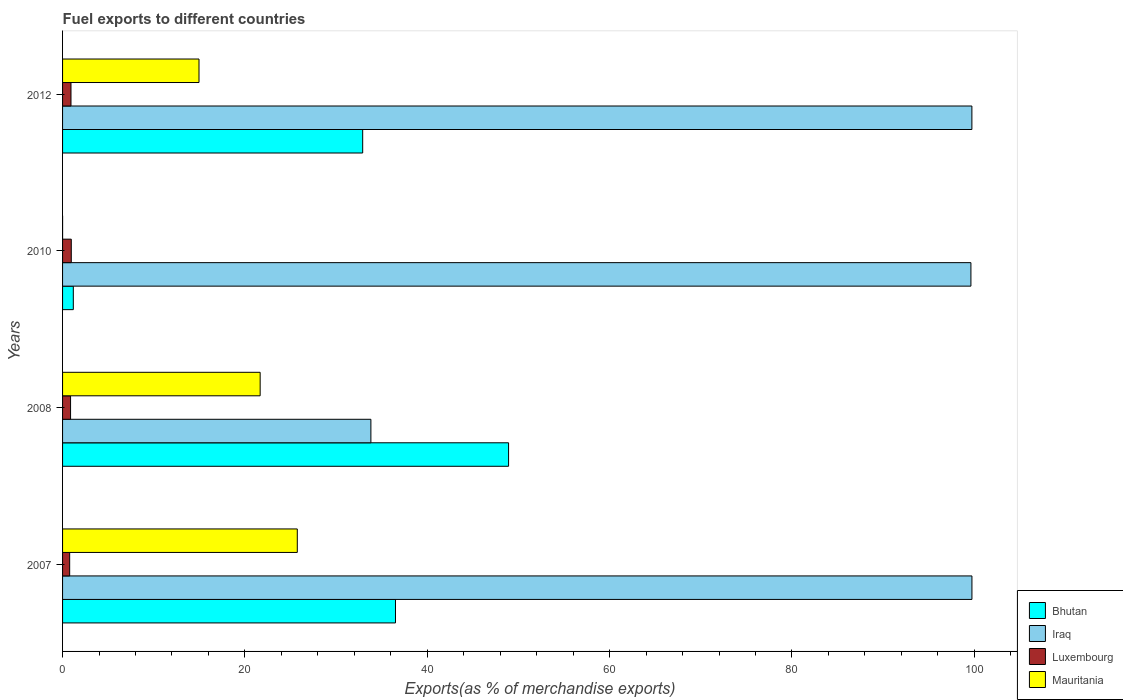How many different coloured bars are there?
Offer a very short reply. 4. How many groups of bars are there?
Offer a terse response. 4. What is the label of the 3rd group of bars from the top?
Offer a terse response. 2008. In how many cases, is the number of bars for a given year not equal to the number of legend labels?
Your answer should be very brief. 0. What is the percentage of exports to different countries in Mauritania in 2010?
Your answer should be very brief. 0. Across all years, what is the maximum percentage of exports to different countries in Iraq?
Make the answer very short. 99.74. Across all years, what is the minimum percentage of exports to different countries in Iraq?
Your response must be concise. 33.82. In which year was the percentage of exports to different countries in Luxembourg maximum?
Ensure brevity in your answer.  2010. What is the total percentage of exports to different countries in Luxembourg in the graph?
Offer a terse response. 3.53. What is the difference between the percentage of exports to different countries in Luxembourg in 2008 and that in 2012?
Provide a short and direct response. -0.05. What is the difference between the percentage of exports to different countries in Bhutan in 2010 and the percentage of exports to different countries in Luxembourg in 2012?
Keep it short and to the point. 0.26. What is the average percentage of exports to different countries in Luxembourg per year?
Provide a short and direct response. 0.88. In the year 2007, what is the difference between the percentage of exports to different countries in Bhutan and percentage of exports to different countries in Iraq?
Provide a short and direct response. -63.23. In how many years, is the percentage of exports to different countries in Mauritania greater than 68 %?
Give a very brief answer. 0. What is the ratio of the percentage of exports to different countries in Iraq in 2010 to that in 2012?
Provide a succinct answer. 1. Is the percentage of exports to different countries in Bhutan in 2010 less than that in 2012?
Your response must be concise. Yes. What is the difference between the highest and the second highest percentage of exports to different countries in Mauritania?
Your response must be concise. 4.07. What is the difference between the highest and the lowest percentage of exports to different countries in Mauritania?
Your response must be concise. 25.74. In how many years, is the percentage of exports to different countries in Iraq greater than the average percentage of exports to different countries in Iraq taken over all years?
Make the answer very short. 3. Is it the case that in every year, the sum of the percentage of exports to different countries in Bhutan and percentage of exports to different countries in Luxembourg is greater than the sum of percentage of exports to different countries in Iraq and percentage of exports to different countries in Mauritania?
Provide a short and direct response. No. What does the 4th bar from the top in 2010 represents?
Offer a terse response. Bhutan. What does the 4th bar from the bottom in 2012 represents?
Your answer should be very brief. Mauritania. How many bars are there?
Your answer should be compact. 16. Are all the bars in the graph horizontal?
Ensure brevity in your answer.  Yes. Does the graph contain any zero values?
Ensure brevity in your answer.  No. What is the title of the graph?
Offer a terse response. Fuel exports to different countries. Does "Congo (Democratic)" appear as one of the legend labels in the graph?
Make the answer very short. No. What is the label or title of the X-axis?
Offer a terse response. Exports(as % of merchandise exports). What is the Exports(as % of merchandise exports) in Bhutan in 2007?
Ensure brevity in your answer.  36.51. What is the Exports(as % of merchandise exports) in Iraq in 2007?
Offer a very short reply. 99.74. What is the Exports(as % of merchandise exports) of Luxembourg in 2007?
Give a very brief answer. 0.78. What is the Exports(as % of merchandise exports) in Mauritania in 2007?
Your answer should be compact. 25.74. What is the Exports(as % of merchandise exports) in Bhutan in 2008?
Provide a short and direct response. 48.92. What is the Exports(as % of merchandise exports) of Iraq in 2008?
Your answer should be very brief. 33.82. What is the Exports(as % of merchandise exports) of Luxembourg in 2008?
Provide a short and direct response. 0.88. What is the Exports(as % of merchandise exports) in Mauritania in 2008?
Provide a succinct answer. 21.67. What is the Exports(as % of merchandise exports) of Bhutan in 2010?
Offer a very short reply. 1.18. What is the Exports(as % of merchandise exports) of Iraq in 2010?
Provide a succinct answer. 99.63. What is the Exports(as % of merchandise exports) in Luxembourg in 2010?
Your answer should be very brief. 0.96. What is the Exports(as % of merchandise exports) of Mauritania in 2010?
Your response must be concise. 0. What is the Exports(as % of merchandise exports) of Bhutan in 2012?
Keep it short and to the point. 32.92. What is the Exports(as % of merchandise exports) in Iraq in 2012?
Keep it short and to the point. 99.73. What is the Exports(as % of merchandise exports) of Luxembourg in 2012?
Offer a very short reply. 0.92. What is the Exports(as % of merchandise exports) of Mauritania in 2012?
Provide a short and direct response. 14.96. Across all years, what is the maximum Exports(as % of merchandise exports) in Bhutan?
Give a very brief answer. 48.92. Across all years, what is the maximum Exports(as % of merchandise exports) in Iraq?
Keep it short and to the point. 99.74. Across all years, what is the maximum Exports(as % of merchandise exports) of Luxembourg?
Give a very brief answer. 0.96. Across all years, what is the maximum Exports(as % of merchandise exports) of Mauritania?
Your answer should be compact. 25.74. Across all years, what is the minimum Exports(as % of merchandise exports) of Bhutan?
Offer a terse response. 1.18. Across all years, what is the minimum Exports(as % of merchandise exports) in Iraq?
Provide a succinct answer. 33.82. Across all years, what is the minimum Exports(as % of merchandise exports) in Luxembourg?
Your answer should be compact. 0.78. Across all years, what is the minimum Exports(as % of merchandise exports) in Mauritania?
Your answer should be compact. 0. What is the total Exports(as % of merchandise exports) in Bhutan in the graph?
Offer a very short reply. 119.53. What is the total Exports(as % of merchandise exports) in Iraq in the graph?
Provide a succinct answer. 332.92. What is the total Exports(as % of merchandise exports) of Luxembourg in the graph?
Keep it short and to the point. 3.53. What is the total Exports(as % of merchandise exports) of Mauritania in the graph?
Offer a very short reply. 62.38. What is the difference between the Exports(as % of merchandise exports) in Bhutan in 2007 and that in 2008?
Provide a succinct answer. -12.4. What is the difference between the Exports(as % of merchandise exports) in Iraq in 2007 and that in 2008?
Offer a terse response. 65.92. What is the difference between the Exports(as % of merchandise exports) in Luxembourg in 2007 and that in 2008?
Your response must be concise. -0.1. What is the difference between the Exports(as % of merchandise exports) of Mauritania in 2007 and that in 2008?
Keep it short and to the point. 4.07. What is the difference between the Exports(as % of merchandise exports) of Bhutan in 2007 and that in 2010?
Provide a succinct answer. 35.34. What is the difference between the Exports(as % of merchandise exports) of Iraq in 2007 and that in 2010?
Offer a terse response. 0.11. What is the difference between the Exports(as % of merchandise exports) of Luxembourg in 2007 and that in 2010?
Ensure brevity in your answer.  -0.18. What is the difference between the Exports(as % of merchandise exports) of Mauritania in 2007 and that in 2010?
Offer a terse response. 25.74. What is the difference between the Exports(as % of merchandise exports) of Bhutan in 2007 and that in 2012?
Provide a short and direct response. 3.6. What is the difference between the Exports(as % of merchandise exports) in Iraq in 2007 and that in 2012?
Provide a succinct answer. 0.01. What is the difference between the Exports(as % of merchandise exports) in Luxembourg in 2007 and that in 2012?
Provide a succinct answer. -0.14. What is the difference between the Exports(as % of merchandise exports) in Mauritania in 2007 and that in 2012?
Offer a very short reply. 10.78. What is the difference between the Exports(as % of merchandise exports) of Bhutan in 2008 and that in 2010?
Ensure brevity in your answer.  47.74. What is the difference between the Exports(as % of merchandise exports) of Iraq in 2008 and that in 2010?
Your response must be concise. -65.81. What is the difference between the Exports(as % of merchandise exports) in Luxembourg in 2008 and that in 2010?
Provide a short and direct response. -0.08. What is the difference between the Exports(as % of merchandise exports) in Mauritania in 2008 and that in 2010?
Offer a terse response. 21.67. What is the difference between the Exports(as % of merchandise exports) in Bhutan in 2008 and that in 2012?
Provide a short and direct response. 16. What is the difference between the Exports(as % of merchandise exports) of Iraq in 2008 and that in 2012?
Ensure brevity in your answer.  -65.92. What is the difference between the Exports(as % of merchandise exports) in Luxembourg in 2008 and that in 2012?
Offer a very short reply. -0.05. What is the difference between the Exports(as % of merchandise exports) of Mauritania in 2008 and that in 2012?
Provide a short and direct response. 6.71. What is the difference between the Exports(as % of merchandise exports) of Bhutan in 2010 and that in 2012?
Ensure brevity in your answer.  -31.74. What is the difference between the Exports(as % of merchandise exports) of Iraq in 2010 and that in 2012?
Provide a succinct answer. -0.11. What is the difference between the Exports(as % of merchandise exports) of Luxembourg in 2010 and that in 2012?
Give a very brief answer. 0.03. What is the difference between the Exports(as % of merchandise exports) in Mauritania in 2010 and that in 2012?
Make the answer very short. -14.96. What is the difference between the Exports(as % of merchandise exports) of Bhutan in 2007 and the Exports(as % of merchandise exports) of Iraq in 2008?
Provide a short and direct response. 2.7. What is the difference between the Exports(as % of merchandise exports) in Bhutan in 2007 and the Exports(as % of merchandise exports) in Luxembourg in 2008?
Your answer should be very brief. 35.64. What is the difference between the Exports(as % of merchandise exports) of Bhutan in 2007 and the Exports(as % of merchandise exports) of Mauritania in 2008?
Give a very brief answer. 14.84. What is the difference between the Exports(as % of merchandise exports) in Iraq in 2007 and the Exports(as % of merchandise exports) in Luxembourg in 2008?
Make the answer very short. 98.86. What is the difference between the Exports(as % of merchandise exports) of Iraq in 2007 and the Exports(as % of merchandise exports) of Mauritania in 2008?
Keep it short and to the point. 78.07. What is the difference between the Exports(as % of merchandise exports) in Luxembourg in 2007 and the Exports(as % of merchandise exports) in Mauritania in 2008?
Provide a short and direct response. -20.89. What is the difference between the Exports(as % of merchandise exports) of Bhutan in 2007 and the Exports(as % of merchandise exports) of Iraq in 2010?
Keep it short and to the point. -63.11. What is the difference between the Exports(as % of merchandise exports) of Bhutan in 2007 and the Exports(as % of merchandise exports) of Luxembourg in 2010?
Offer a very short reply. 35.56. What is the difference between the Exports(as % of merchandise exports) of Bhutan in 2007 and the Exports(as % of merchandise exports) of Mauritania in 2010?
Make the answer very short. 36.51. What is the difference between the Exports(as % of merchandise exports) in Iraq in 2007 and the Exports(as % of merchandise exports) in Luxembourg in 2010?
Give a very brief answer. 98.78. What is the difference between the Exports(as % of merchandise exports) of Iraq in 2007 and the Exports(as % of merchandise exports) of Mauritania in 2010?
Offer a very short reply. 99.74. What is the difference between the Exports(as % of merchandise exports) of Luxembourg in 2007 and the Exports(as % of merchandise exports) of Mauritania in 2010?
Ensure brevity in your answer.  0.78. What is the difference between the Exports(as % of merchandise exports) in Bhutan in 2007 and the Exports(as % of merchandise exports) in Iraq in 2012?
Offer a very short reply. -63.22. What is the difference between the Exports(as % of merchandise exports) in Bhutan in 2007 and the Exports(as % of merchandise exports) in Luxembourg in 2012?
Keep it short and to the point. 35.59. What is the difference between the Exports(as % of merchandise exports) in Bhutan in 2007 and the Exports(as % of merchandise exports) in Mauritania in 2012?
Ensure brevity in your answer.  21.55. What is the difference between the Exports(as % of merchandise exports) of Iraq in 2007 and the Exports(as % of merchandise exports) of Luxembourg in 2012?
Your response must be concise. 98.82. What is the difference between the Exports(as % of merchandise exports) in Iraq in 2007 and the Exports(as % of merchandise exports) in Mauritania in 2012?
Provide a succinct answer. 84.78. What is the difference between the Exports(as % of merchandise exports) in Luxembourg in 2007 and the Exports(as % of merchandise exports) in Mauritania in 2012?
Give a very brief answer. -14.18. What is the difference between the Exports(as % of merchandise exports) in Bhutan in 2008 and the Exports(as % of merchandise exports) in Iraq in 2010?
Ensure brevity in your answer.  -50.71. What is the difference between the Exports(as % of merchandise exports) in Bhutan in 2008 and the Exports(as % of merchandise exports) in Luxembourg in 2010?
Your response must be concise. 47.96. What is the difference between the Exports(as % of merchandise exports) of Bhutan in 2008 and the Exports(as % of merchandise exports) of Mauritania in 2010?
Offer a very short reply. 48.92. What is the difference between the Exports(as % of merchandise exports) of Iraq in 2008 and the Exports(as % of merchandise exports) of Luxembourg in 2010?
Your answer should be compact. 32.86. What is the difference between the Exports(as % of merchandise exports) of Iraq in 2008 and the Exports(as % of merchandise exports) of Mauritania in 2010?
Offer a terse response. 33.82. What is the difference between the Exports(as % of merchandise exports) in Luxembourg in 2008 and the Exports(as % of merchandise exports) in Mauritania in 2010?
Keep it short and to the point. 0.87. What is the difference between the Exports(as % of merchandise exports) of Bhutan in 2008 and the Exports(as % of merchandise exports) of Iraq in 2012?
Ensure brevity in your answer.  -50.82. What is the difference between the Exports(as % of merchandise exports) of Bhutan in 2008 and the Exports(as % of merchandise exports) of Luxembourg in 2012?
Your answer should be very brief. 47.99. What is the difference between the Exports(as % of merchandise exports) in Bhutan in 2008 and the Exports(as % of merchandise exports) in Mauritania in 2012?
Offer a terse response. 33.95. What is the difference between the Exports(as % of merchandise exports) of Iraq in 2008 and the Exports(as % of merchandise exports) of Luxembourg in 2012?
Your answer should be compact. 32.89. What is the difference between the Exports(as % of merchandise exports) in Iraq in 2008 and the Exports(as % of merchandise exports) in Mauritania in 2012?
Offer a terse response. 18.85. What is the difference between the Exports(as % of merchandise exports) of Luxembourg in 2008 and the Exports(as % of merchandise exports) of Mauritania in 2012?
Offer a terse response. -14.09. What is the difference between the Exports(as % of merchandise exports) in Bhutan in 2010 and the Exports(as % of merchandise exports) in Iraq in 2012?
Provide a short and direct response. -98.55. What is the difference between the Exports(as % of merchandise exports) of Bhutan in 2010 and the Exports(as % of merchandise exports) of Luxembourg in 2012?
Your response must be concise. 0.26. What is the difference between the Exports(as % of merchandise exports) of Bhutan in 2010 and the Exports(as % of merchandise exports) of Mauritania in 2012?
Offer a very short reply. -13.78. What is the difference between the Exports(as % of merchandise exports) of Iraq in 2010 and the Exports(as % of merchandise exports) of Luxembourg in 2012?
Provide a succinct answer. 98.7. What is the difference between the Exports(as % of merchandise exports) of Iraq in 2010 and the Exports(as % of merchandise exports) of Mauritania in 2012?
Keep it short and to the point. 84.66. What is the difference between the Exports(as % of merchandise exports) of Luxembourg in 2010 and the Exports(as % of merchandise exports) of Mauritania in 2012?
Offer a terse response. -14.01. What is the average Exports(as % of merchandise exports) in Bhutan per year?
Offer a very short reply. 29.88. What is the average Exports(as % of merchandise exports) of Iraq per year?
Offer a terse response. 83.23. What is the average Exports(as % of merchandise exports) in Luxembourg per year?
Your answer should be compact. 0.88. What is the average Exports(as % of merchandise exports) of Mauritania per year?
Your response must be concise. 15.6. In the year 2007, what is the difference between the Exports(as % of merchandise exports) of Bhutan and Exports(as % of merchandise exports) of Iraq?
Give a very brief answer. -63.23. In the year 2007, what is the difference between the Exports(as % of merchandise exports) in Bhutan and Exports(as % of merchandise exports) in Luxembourg?
Provide a short and direct response. 35.74. In the year 2007, what is the difference between the Exports(as % of merchandise exports) in Bhutan and Exports(as % of merchandise exports) in Mauritania?
Offer a terse response. 10.77. In the year 2007, what is the difference between the Exports(as % of merchandise exports) of Iraq and Exports(as % of merchandise exports) of Luxembourg?
Make the answer very short. 98.96. In the year 2007, what is the difference between the Exports(as % of merchandise exports) in Iraq and Exports(as % of merchandise exports) in Mauritania?
Make the answer very short. 74. In the year 2007, what is the difference between the Exports(as % of merchandise exports) of Luxembourg and Exports(as % of merchandise exports) of Mauritania?
Make the answer very short. -24.97. In the year 2008, what is the difference between the Exports(as % of merchandise exports) of Bhutan and Exports(as % of merchandise exports) of Iraq?
Keep it short and to the point. 15.1. In the year 2008, what is the difference between the Exports(as % of merchandise exports) of Bhutan and Exports(as % of merchandise exports) of Luxembourg?
Keep it short and to the point. 48.04. In the year 2008, what is the difference between the Exports(as % of merchandise exports) of Bhutan and Exports(as % of merchandise exports) of Mauritania?
Your response must be concise. 27.25. In the year 2008, what is the difference between the Exports(as % of merchandise exports) of Iraq and Exports(as % of merchandise exports) of Luxembourg?
Make the answer very short. 32.94. In the year 2008, what is the difference between the Exports(as % of merchandise exports) of Iraq and Exports(as % of merchandise exports) of Mauritania?
Make the answer very short. 12.15. In the year 2008, what is the difference between the Exports(as % of merchandise exports) of Luxembourg and Exports(as % of merchandise exports) of Mauritania?
Make the answer very short. -20.8. In the year 2010, what is the difference between the Exports(as % of merchandise exports) in Bhutan and Exports(as % of merchandise exports) in Iraq?
Provide a short and direct response. -98.45. In the year 2010, what is the difference between the Exports(as % of merchandise exports) in Bhutan and Exports(as % of merchandise exports) in Luxembourg?
Give a very brief answer. 0.22. In the year 2010, what is the difference between the Exports(as % of merchandise exports) of Bhutan and Exports(as % of merchandise exports) of Mauritania?
Your answer should be very brief. 1.18. In the year 2010, what is the difference between the Exports(as % of merchandise exports) in Iraq and Exports(as % of merchandise exports) in Luxembourg?
Ensure brevity in your answer.  98.67. In the year 2010, what is the difference between the Exports(as % of merchandise exports) of Iraq and Exports(as % of merchandise exports) of Mauritania?
Your answer should be very brief. 99.62. In the year 2010, what is the difference between the Exports(as % of merchandise exports) in Luxembourg and Exports(as % of merchandise exports) in Mauritania?
Make the answer very short. 0.95. In the year 2012, what is the difference between the Exports(as % of merchandise exports) in Bhutan and Exports(as % of merchandise exports) in Iraq?
Provide a succinct answer. -66.82. In the year 2012, what is the difference between the Exports(as % of merchandise exports) in Bhutan and Exports(as % of merchandise exports) in Luxembourg?
Offer a very short reply. 31.99. In the year 2012, what is the difference between the Exports(as % of merchandise exports) of Bhutan and Exports(as % of merchandise exports) of Mauritania?
Ensure brevity in your answer.  17.95. In the year 2012, what is the difference between the Exports(as % of merchandise exports) of Iraq and Exports(as % of merchandise exports) of Luxembourg?
Offer a very short reply. 98.81. In the year 2012, what is the difference between the Exports(as % of merchandise exports) in Iraq and Exports(as % of merchandise exports) in Mauritania?
Offer a terse response. 84.77. In the year 2012, what is the difference between the Exports(as % of merchandise exports) in Luxembourg and Exports(as % of merchandise exports) in Mauritania?
Your answer should be compact. -14.04. What is the ratio of the Exports(as % of merchandise exports) of Bhutan in 2007 to that in 2008?
Offer a very short reply. 0.75. What is the ratio of the Exports(as % of merchandise exports) in Iraq in 2007 to that in 2008?
Provide a short and direct response. 2.95. What is the ratio of the Exports(as % of merchandise exports) in Luxembourg in 2007 to that in 2008?
Your response must be concise. 0.89. What is the ratio of the Exports(as % of merchandise exports) in Mauritania in 2007 to that in 2008?
Ensure brevity in your answer.  1.19. What is the ratio of the Exports(as % of merchandise exports) of Bhutan in 2007 to that in 2010?
Offer a very short reply. 30.96. What is the ratio of the Exports(as % of merchandise exports) in Iraq in 2007 to that in 2010?
Keep it short and to the point. 1. What is the ratio of the Exports(as % of merchandise exports) in Luxembourg in 2007 to that in 2010?
Your response must be concise. 0.81. What is the ratio of the Exports(as % of merchandise exports) in Mauritania in 2007 to that in 2010?
Your response must be concise. 1.56e+04. What is the ratio of the Exports(as % of merchandise exports) in Bhutan in 2007 to that in 2012?
Your answer should be very brief. 1.11. What is the ratio of the Exports(as % of merchandise exports) of Iraq in 2007 to that in 2012?
Offer a very short reply. 1. What is the ratio of the Exports(as % of merchandise exports) of Luxembourg in 2007 to that in 2012?
Your answer should be compact. 0.84. What is the ratio of the Exports(as % of merchandise exports) in Mauritania in 2007 to that in 2012?
Make the answer very short. 1.72. What is the ratio of the Exports(as % of merchandise exports) of Bhutan in 2008 to that in 2010?
Your response must be concise. 41.48. What is the ratio of the Exports(as % of merchandise exports) of Iraq in 2008 to that in 2010?
Give a very brief answer. 0.34. What is the ratio of the Exports(as % of merchandise exports) of Luxembourg in 2008 to that in 2010?
Provide a succinct answer. 0.92. What is the ratio of the Exports(as % of merchandise exports) of Mauritania in 2008 to that in 2010?
Keep it short and to the point. 1.31e+04. What is the ratio of the Exports(as % of merchandise exports) of Bhutan in 2008 to that in 2012?
Your answer should be very brief. 1.49. What is the ratio of the Exports(as % of merchandise exports) of Iraq in 2008 to that in 2012?
Give a very brief answer. 0.34. What is the ratio of the Exports(as % of merchandise exports) of Luxembourg in 2008 to that in 2012?
Give a very brief answer. 0.95. What is the ratio of the Exports(as % of merchandise exports) in Mauritania in 2008 to that in 2012?
Offer a terse response. 1.45. What is the ratio of the Exports(as % of merchandise exports) in Bhutan in 2010 to that in 2012?
Provide a succinct answer. 0.04. What is the ratio of the Exports(as % of merchandise exports) in Luxembourg in 2010 to that in 2012?
Your response must be concise. 1.03. What is the ratio of the Exports(as % of merchandise exports) of Mauritania in 2010 to that in 2012?
Offer a terse response. 0. What is the difference between the highest and the second highest Exports(as % of merchandise exports) of Bhutan?
Make the answer very short. 12.4. What is the difference between the highest and the second highest Exports(as % of merchandise exports) of Iraq?
Keep it short and to the point. 0.01. What is the difference between the highest and the second highest Exports(as % of merchandise exports) of Luxembourg?
Offer a terse response. 0.03. What is the difference between the highest and the second highest Exports(as % of merchandise exports) of Mauritania?
Make the answer very short. 4.07. What is the difference between the highest and the lowest Exports(as % of merchandise exports) in Bhutan?
Offer a very short reply. 47.74. What is the difference between the highest and the lowest Exports(as % of merchandise exports) of Iraq?
Give a very brief answer. 65.92. What is the difference between the highest and the lowest Exports(as % of merchandise exports) in Luxembourg?
Give a very brief answer. 0.18. What is the difference between the highest and the lowest Exports(as % of merchandise exports) of Mauritania?
Give a very brief answer. 25.74. 